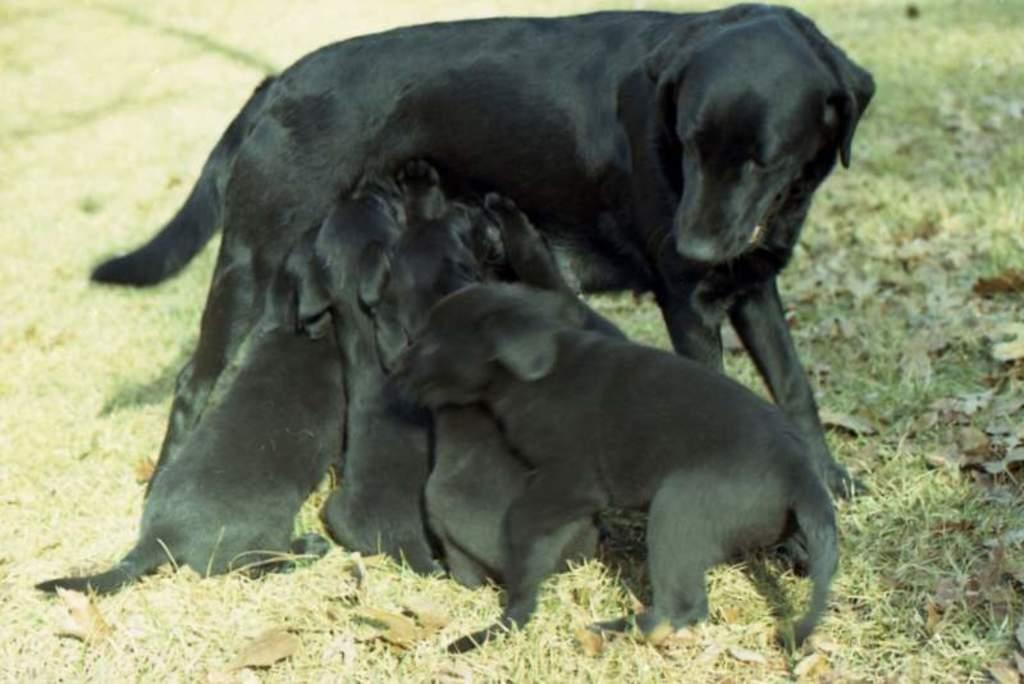What type of animal is present in the image? There is a dog in the image. Are there any other animals in the image? Yes, there are puppies in the image. What can be seen in the background of the image? There is ground visible in the background of the image. How many fingers can be seen on the dog's paw in the image? Dogs do not have fingers; they have paw pads. Therefore, there are no fingers visible on the dog's paw in the image. 